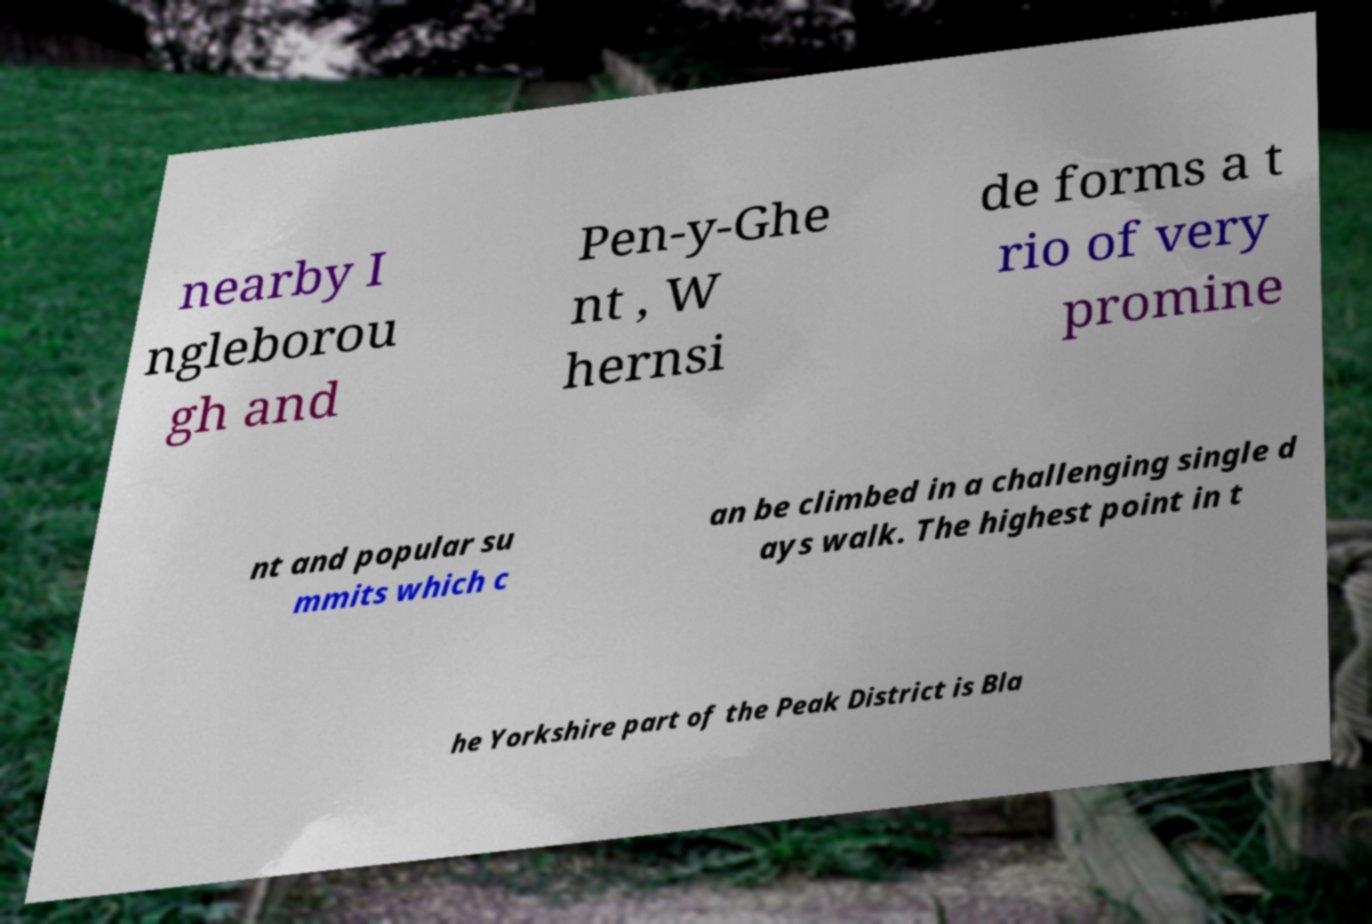For documentation purposes, I need the text within this image transcribed. Could you provide that? nearby I ngleborou gh and Pen-y-Ghe nt , W hernsi de forms a t rio of very promine nt and popular su mmits which c an be climbed in a challenging single d ays walk. The highest point in t he Yorkshire part of the Peak District is Bla 